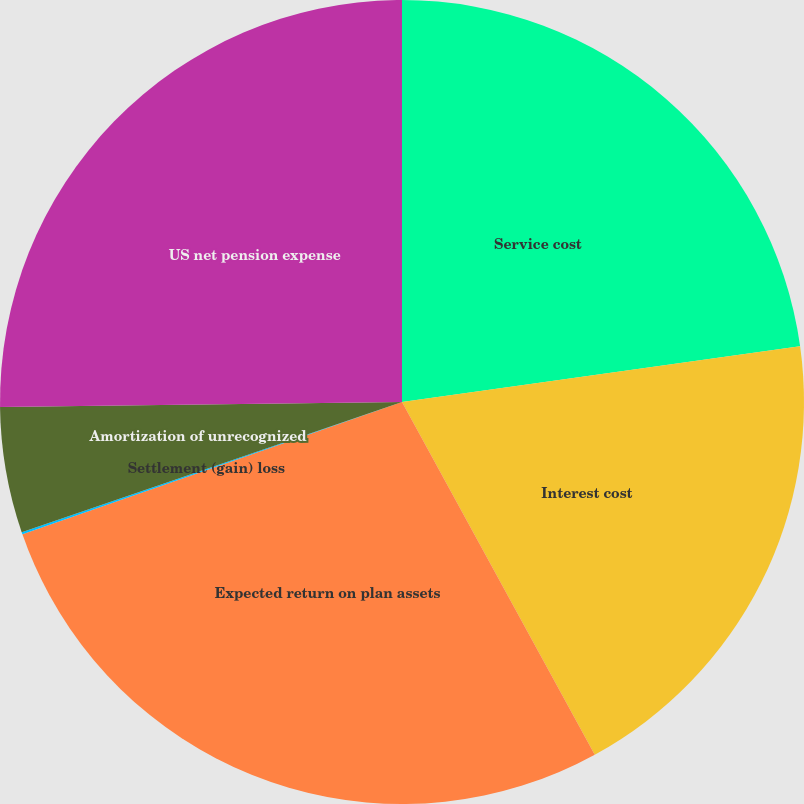<chart> <loc_0><loc_0><loc_500><loc_500><pie_chart><fcel>Service cost<fcel>Interest cost<fcel>Expected return on plan assets<fcel>Settlement (gain) loss<fcel>Amortization of unrecognized<fcel>US net pension expense<nl><fcel>22.79%<fcel>19.25%<fcel>27.62%<fcel>0.09%<fcel>5.05%<fcel>25.2%<nl></chart> 